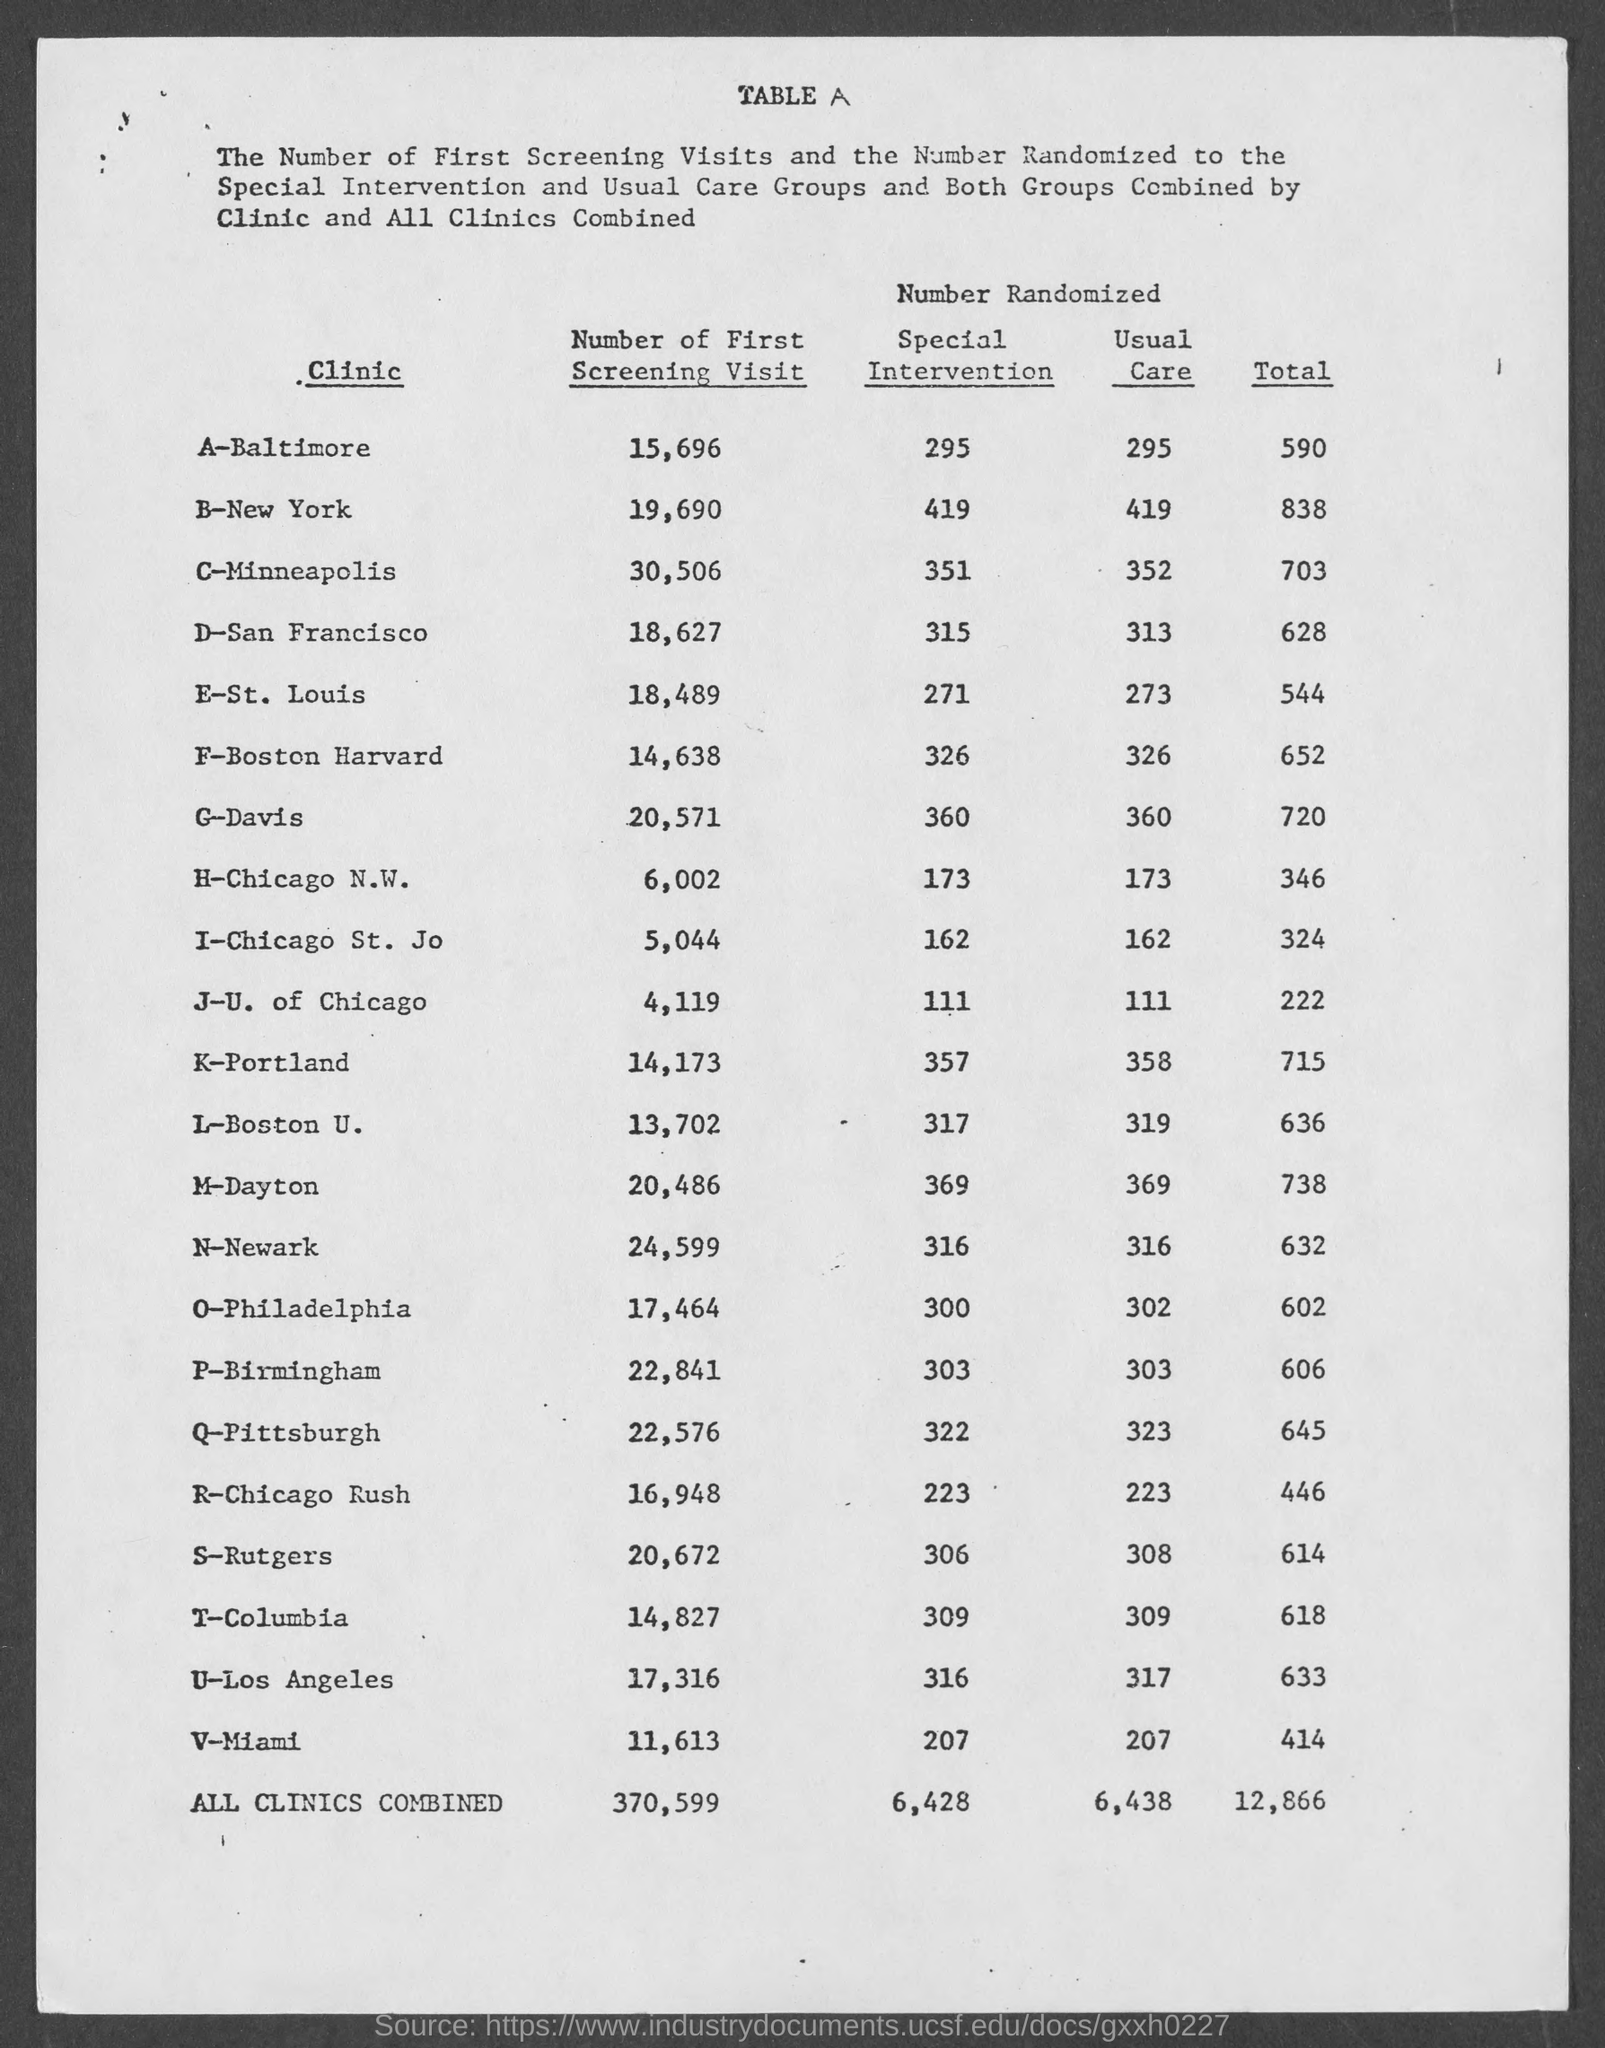What is the number of first screening visit in the clinic K-Portland?
Your answer should be very brief. 14,173. What is the number of first screening visit in the clinic G-Davis?
Give a very brief answer. 20,571. What is the number of usual care in the clinic A-Baltimore?
Ensure brevity in your answer.  295. What is the number of usual care in the clinic B-New York?
Your answer should be very brief. 419. What is the number of usual care in the clinic C-Minneapolis?
Keep it short and to the point. 352. What is the number of first screening visit in the clinic V-Miami?
Keep it short and to the point. 11,613. 